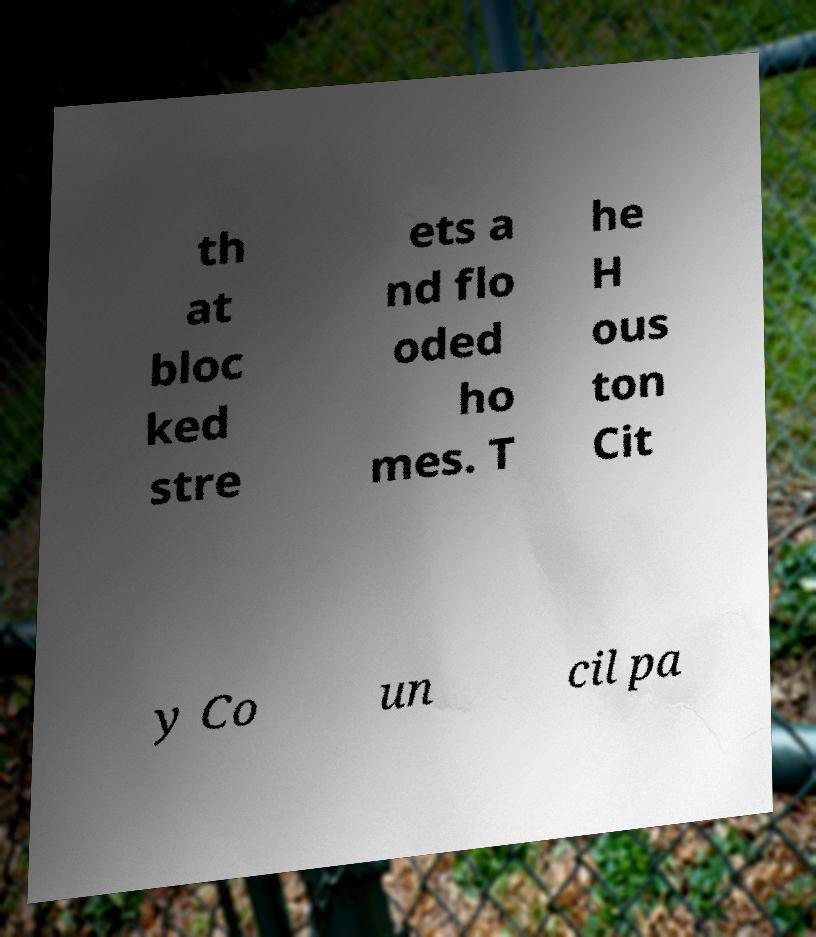Please read and relay the text visible in this image. What does it say? th at bloc ked stre ets a nd flo oded ho mes. T he H ous ton Cit y Co un cil pa 